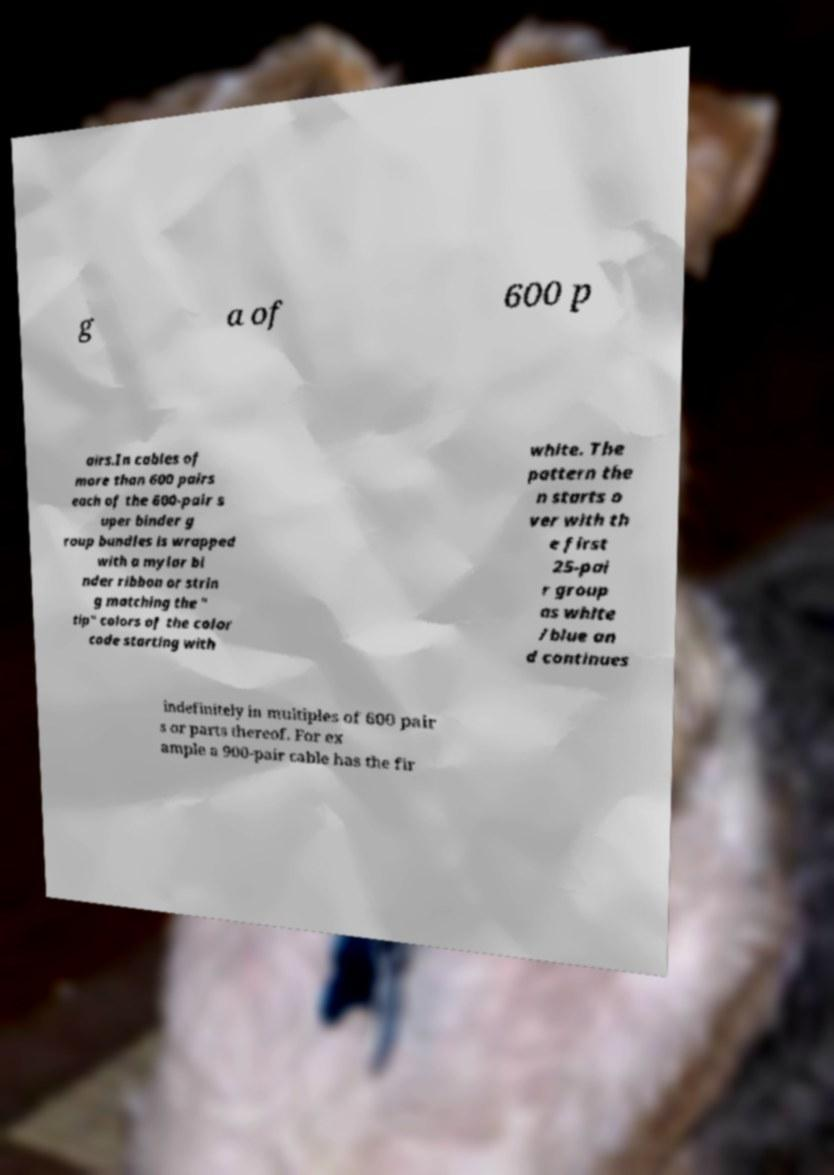Please identify and transcribe the text found in this image. g a of 600 p airs.In cables of more than 600 pairs each of the 600-pair s uper binder g roup bundles is wrapped with a mylar bi nder ribbon or strin g matching the " tip" colors of the color code starting with white. The pattern the n starts o ver with th e first 25-pai r group as white /blue an d continues indefinitely in multiples of 600 pair s or parts thereof. For ex ample a 900-pair cable has the fir 